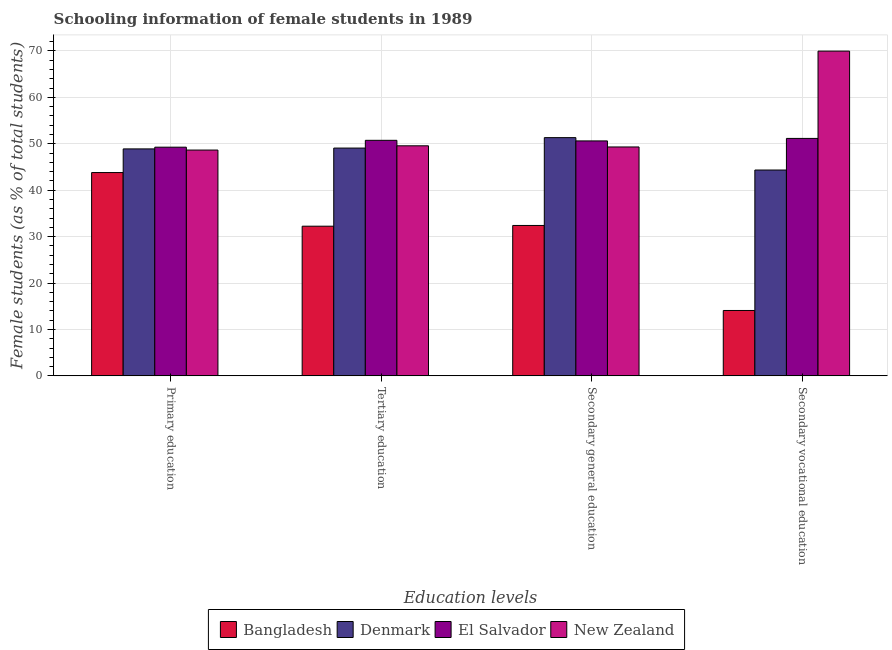How many different coloured bars are there?
Provide a short and direct response. 4. Are the number of bars per tick equal to the number of legend labels?
Provide a short and direct response. Yes. Are the number of bars on each tick of the X-axis equal?
Give a very brief answer. Yes. How many bars are there on the 1st tick from the left?
Give a very brief answer. 4. What is the label of the 1st group of bars from the left?
Your answer should be very brief. Primary education. What is the percentage of female students in primary education in Bangladesh?
Give a very brief answer. 43.8. Across all countries, what is the maximum percentage of female students in secondary vocational education?
Your answer should be very brief. 69.96. Across all countries, what is the minimum percentage of female students in secondary vocational education?
Offer a very short reply. 14.09. In which country was the percentage of female students in tertiary education maximum?
Offer a terse response. El Salvador. What is the total percentage of female students in secondary education in the graph?
Ensure brevity in your answer.  183.65. What is the difference between the percentage of female students in secondary vocational education in New Zealand and that in Bangladesh?
Keep it short and to the point. 55.87. What is the difference between the percentage of female students in tertiary education in Bangladesh and the percentage of female students in secondary vocational education in Denmark?
Offer a very short reply. -12.1. What is the average percentage of female students in primary education per country?
Make the answer very short. 47.65. What is the difference between the percentage of female students in primary education and percentage of female students in secondary vocational education in Denmark?
Provide a short and direct response. 4.55. What is the ratio of the percentage of female students in secondary education in El Salvador to that in New Zealand?
Offer a very short reply. 1.03. Is the difference between the percentage of female students in primary education in Bangladesh and New Zealand greater than the difference between the percentage of female students in secondary education in Bangladesh and New Zealand?
Provide a short and direct response. Yes. What is the difference between the highest and the second highest percentage of female students in secondary vocational education?
Offer a terse response. 18.81. What is the difference between the highest and the lowest percentage of female students in primary education?
Your answer should be compact. 5.46. In how many countries, is the percentage of female students in primary education greater than the average percentage of female students in primary education taken over all countries?
Provide a succinct answer. 3. What does the 3rd bar from the left in Tertiary education represents?
Provide a short and direct response. El Salvador. Is it the case that in every country, the sum of the percentage of female students in primary education and percentage of female students in tertiary education is greater than the percentage of female students in secondary education?
Provide a short and direct response. Yes. How many countries are there in the graph?
Ensure brevity in your answer.  4. What is the difference between two consecutive major ticks on the Y-axis?
Give a very brief answer. 10. Are the values on the major ticks of Y-axis written in scientific E-notation?
Provide a short and direct response. No. What is the title of the graph?
Your response must be concise. Schooling information of female students in 1989. What is the label or title of the X-axis?
Provide a short and direct response. Education levels. What is the label or title of the Y-axis?
Provide a short and direct response. Female students (as % of total students). What is the Female students (as % of total students) of Bangladesh in Primary education?
Ensure brevity in your answer.  43.8. What is the Female students (as % of total students) in Denmark in Primary education?
Your response must be concise. 48.89. What is the Female students (as % of total students) of El Salvador in Primary education?
Your answer should be very brief. 49.27. What is the Female students (as % of total students) in New Zealand in Primary education?
Ensure brevity in your answer.  48.64. What is the Female students (as % of total students) in Bangladesh in Tertiary education?
Offer a terse response. 32.24. What is the Female students (as % of total students) in Denmark in Tertiary education?
Your answer should be very brief. 49.07. What is the Female students (as % of total students) in El Salvador in Tertiary education?
Your answer should be very brief. 50.74. What is the Female students (as % of total students) in New Zealand in Tertiary education?
Ensure brevity in your answer.  49.56. What is the Female students (as % of total students) in Bangladesh in Secondary general education?
Make the answer very short. 32.4. What is the Female students (as % of total students) of Denmark in Secondary general education?
Ensure brevity in your answer.  51.32. What is the Female students (as % of total students) of El Salvador in Secondary general education?
Your response must be concise. 50.61. What is the Female students (as % of total students) of New Zealand in Secondary general education?
Keep it short and to the point. 49.31. What is the Female students (as % of total students) of Bangladesh in Secondary vocational education?
Offer a terse response. 14.09. What is the Female students (as % of total students) in Denmark in Secondary vocational education?
Provide a short and direct response. 44.34. What is the Female students (as % of total students) of El Salvador in Secondary vocational education?
Give a very brief answer. 51.16. What is the Female students (as % of total students) in New Zealand in Secondary vocational education?
Ensure brevity in your answer.  69.96. Across all Education levels, what is the maximum Female students (as % of total students) of Bangladesh?
Your answer should be compact. 43.8. Across all Education levels, what is the maximum Female students (as % of total students) in Denmark?
Your answer should be compact. 51.32. Across all Education levels, what is the maximum Female students (as % of total students) in El Salvador?
Your answer should be very brief. 51.16. Across all Education levels, what is the maximum Female students (as % of total students) in New Zealand?
Make the answer very short. 69.96. Across all Education levels, what is the minimum Female students (as % of total students) of Bangladesh?
Your response must be concise. 14.09. Across all Education levels, what is the minimum Female students (as % of total students) of Denmark?
Offer a very short reply. 44.34. Across all Education levels, what is the minimum Female students (as % of total students) in El Salvador?
Offer a very short reply. 49.27. Across all Education levels, what is the minimum Female students (as % of total students) of New Zealand?
Your answer should be compact. 48.64. What is the total Female students (as % of total students) in Bangladesh in the graph?
Offer a terse response. 122.53. What is the total Female students (as % of total students) in Denmark in the graph?
Offer a very short reply. 193.63. What is the total Female students (as % of total students) of El Salvador in the graph?
Give a very brief answer. 201.78. What is the total Female students (as % of total students) in New Zealand in the graph?
Give a very brief answer. 217.48. What is the difference between the Female students (as % of total students) of Bangladesh in Primary education and that in Tertiary education?
Your answer should be compact. 11.56. What is the difference between the Female students (as % of total students) in Denmark in Primary education and that in Tertiary education?
Make the answer very short. -0.18. What is the difference between the Female students (as % of total students) of El Salvador in Primary education and that in Tertiary education?
Give a very brief answer. -1.48. What is the difference between the Female students (as % of total students) in New Zealand in Primary education and that in Tertiary education?
Offer a terse response. -0.92. What is the difference between the Female students (as % of total students) in Bangladesh in Primary education and that in Secondary general education?
Your answer should be compact. 11.4. What is the difference between the Female students (as % of total students) in Denmark in Primary education and that in Secondary general education?
Make the answer very short. -2.43. What is the difference between the Female students (as % of total students) of El Salvador in Primary education and that in Secondary general education?
Provide a succinct answer. -1.35. What is the difference between the Female students (as % of total students) of New Zealand in Primary education and that in Secondary general education?
Your answer should be compact. -0.67. What is the difference between the Female students (as % of total students) of Bangladesh in Primary education and that in Secondary vocational education?
Keep it short and to the point. 29.71. What is the difference between the Female students (as % of total students) in Denmark in Primary education and that in Secondary vocational education?
Give a very brief answer. 4.55. What is the difference between the Female students (as % of total students) of El Salvador in Primary education and that in Secondary vocational education?
Provide a succinct answer. -1.89. What is the difference between the Female students (as % of total students) in New Zealand in Primary education and that in Secondary vocational education?
Offer a terse response. -21.32. What is the difference between the Female students (as % of total students) in Bangladesh in Tertiary education and that in Secondary general education?
Your answer should be compact. -0.16. What is the difference between the Female students (as % of total students) in Denmark in Tertiary education and that in Secondary general education?
Your response must be concise. -2.25. What is the difference between the Female students (as % of total students) of El Salvador in Tertiary education and that in Secondary general education?
Keep it short and to the point. 0.13. What is the difference between the Female students (as % of total students) in New Zealand in Tertiary education and that in Secondary general education?
Ensure brevity in your answer.  0.25. What is the difference between the Female students (as % of total students) in Bangladesh in Tertiary education and that in Secondary vocational education?
Your answer should be very brief. 18.16. What is the difference between the Female students (as % of total students) of Denmark in Tertiary education and that in Secondary vocational education?
Your response must be concise. 4.73. What is the difference between the Female students (as % of total students) of El Salvador in Tertiary education and that in Secondary vocational education?
Give a very brief answer. -0.41. What is the difference between the Female students (as % of total students) of New Zealand in Tertiary education and that in Secondary vocational education?
Make the answer very short. -20.4. What is the difference between the Female students (as % of total students) in Bangladesh in Secondary general education and that in Secondary vocational education?
Offer a terse response. 18.31. What is the difference between the Female students (as % of total students) of Denmark in Secondary general education and that in Secondary vocational education?
Provide a short and direct response. 6.98. What is the difference between the Female students (as % of total students) in El Salvador in Secondary general education and that in Secondary vocational education?
Offer a terse response. -0.54. What is the difference between the Female students (as % of total students) of New Zealand in Secondary general education and that in Secondary vocational education?
Ensure brevity in your answer.  -20.65. What is the difference between the Female students (as % of total students) of Bangladesh in Primary education and the Female students (as % of total students) of Denmark in Tertiary education?
Offer a very short reply. -5.27. What is the difference between the Female students (as % of total students) in Bangladesh in Primary education and the Female students (as % of total students) in El Salvador in Tertiary education?
Give a very brief answer. -6.94. What is the difference between the Female students (as % of total students) in Bangladesh in Primary education and the Female students (as % of total students) in New Zealand in Tertiary education?
Make the answer very short. -5.76. What is the difference between the Female students (as % of total students) in Denmark in Primary education and the Female students (as % of total students) in El Salvador in Tertiary education?
Your response must be concise. -1.85. What is the difference between the Female students (as % of total students) in Denmark in Primary education and the Female students (as % of total students) in New Zealand in Tertiary education?
Provide a short and direct response. -0.67. What is the difference between the Female students (as % of total students) of El Salvador in Primary education and the Female students (as % of total students) of New Zealand in Tertiary education?
Your response must be concise. -0.3. What is the difference between the Female students (as % of total students) in Bangladesh in Primary education and the Female students (as % of total students) in Denmark in Secondary general education?
Provide a short and direct response. -7.52. What is the difference between the Female students (as % of total students) in Bangladesh in Primary education and the Female students (as % of total students) in El Salvador in Secondary general education?
Provide a short and direct response. -6.81. What is the difference between the Female students (as % of total students) of Bangladesh in Primary education and the Female students (as % of total students) of New Zealand in Secondary general education?
Give a very brief answer. -5.51. What is the difference between the Female students (as % of total students) in Denmark in Primary education and the Female students (as % of total students) in El Salvador in Secondary general education?
Give a very brief answer. -1.72. What is the difference between the Female students (as % of total students) of Denmark in Primary education and the Female students (as % of total students) of New Zealand in Secondary general education?
Keep it short and to the point. -0.42. What is the difference between the Female students (as % of total students) in El Salvador in Primary education and the Female students (as % of total students) in New Zealand in Secondary general education?
Ensure brevity in your answer.  -0.05. What is the difference between the Female students (as % of total students) in Bangladesh in Primary education and the Female students (as % of total students) in Denmark in Secondary vocational education?
Ensure brevity in your answer.  -0.54. What is the difference between the Female students (as % of total students) of Bangladesh in Primary education and the Female students (as % of total students) of El Salvador in Secondary vocational education?
Give a very brief answer. -7.36. What is the difference between the Female students (as % of total students) in Bangladesh in Primary education and the Female students (as % of total students) in New Zealand in Secondary vocational education?
Your response must be concise. -26.16. What is the difference between the Female students (as % of total students) of Denmark in Primary education and the Female students (as % of total students) of El Salvador in Secondary vocational education?
Keep it short and to the point. -2.26. What is the difference between the Female students (as % of total students) of Denmark in Primary education and the Female students (as % of total students) of New Zealand in Secondary vocational education?
Make the answer very short. -21.07. What is the difference between the Female students (as % of total students) in El Salvador in Primary education and the Female students (as % of total students) in New Zealand in Secondary vocational education?
Give a very brief answer. -20.7. What is the difference between the Female students (as % of total students) in Bangladesh in Tertiary education and the Female students (as % of total students) in Denmark in Secondary general education?
Make the answer very short. -19.08. What is the difference between the Female students (as % of total students) of Bangladesh in Tertiary education and the Female students (as % of total students) of El Salvador in Secondary general education?
Your answer should be very brief. -18.37. What is the difference between the Female students (as % of total students) in Bangladesh in Tertiary education and the Female students (as % of total students) in New Zealand in Secondary general education?
Ensure brevity in your answer.  -17.07. What is the difference between the Female students (as % of total students) of Denmark in Tertiary education and the Female students (as % of total students) of El Salvador in Secondary general education?
Offer a very short reply. -1.54. What is the difference between the Female students (as % of total students) in Denmark in Tertiary education and the Female students (as % of total students) in New Zealand in Secondary general education?
Your answer should be compact. -0.24. What is the difference between the Female students (as % of total students) of El Salvador in Tertiary education and the Female students (as % of total students) of New Zealand in Secondary general education?
Ensure brevity in your answer.  1.43. What is the difference between the Female students (as % of total students) of Bangladesh in Tertiary education and the Female students (as % of total students) of Denmark in Secondary vocational education?
Your answer should be very brief. -12.1. What is the difference between the Female students (as % of total students) of Bangladesh in Tertiary education and the Female students (as % of total students) of El Salvador in Secondary vocational education?
Make the answer very short. -18.91. What is the difference between the Female students (as % of total students) of Bangladesh in Tertiary education and the Female students (as % of total students) of New Zealand in Secondary vocational education?
Provide a short and direct response. -37.72. What is the difference between the Female students (as % of total students) of Denmark in Tertiary education and the Female students (as % of total students) of El Salvador in Secondary vocational education?
Offer a very short reply. -2.08. What is the difference between the Female students (as % of total students) in Denmark in Tertiary education and the Female students (as % of total students) in New Zealand in Secondary vocational education?
Keep it short and to the point. -20.89. What is the difference between the Female students (as % of total students) of El Salvador in Tertiary education and the Female students (as % of total students) of New Zealand in Secondary vocational education?
Keep it short and to the point. -19.22. What is the difference between the Female students (as % of total students) in Bangladesh in Secondary general education and the Female students (as % of total students) in Denmark in Secondary vocational education?
Offer a terse response. -11.94. What is the difference between the Female students (as % of total students) in Bangladesh in Secondary general education and the Female students (as % of total students) in El Salvador in Secondary vocational education?
Provide a short and direct response. -18.76. What is the difference between the Female students (as % of total students) in Bangladesh in Secondary general education and the Female students (as % of total students) in New Zealand in Secondary vocational education?
Offer a very short reply. -37.56. What is the difference between the Female students (as % of total students) of Denmark in Secondary general education and the Female students (as % of total students) of El Salvador in Secondary vocational education?
Your response must be concise. 0.17. What is the difference between the Female students (as % of total students) of Denmark in Secondary general education and the Female students (as % of total students) of New Zealand in Secondary vocational education?
Your answer should be very brief. -18.64. What is the difference between the Female students (as % of total students) of El Salvador in Secondary general education and the Female students (as % of total students) of New Zealand in Secondary vocational education?
Offer a terse response. -19.35. What is the average Female students (as % of total students) in Bangladesh per Education levels?
Keep it short and to the point. 30.63. What is the average Female students (as % of total students) of Denmark per Education levels?
Your answer should be very brief. 48.41. What is the average Female students (as % of total students) in El Salvador per Education levels?
Offer a very short reply. 50.44. What is the average Female students (as % of total students) in New Zealand per Education levels?
Offer a very short reply. 54.37. What is the difference between the Female students (as % of total students) of Bangladesh and Female students (as % of total students) of Denmark in Primary education?
Offer a very short reply. -5.09. What is the difference between the Female students (as % of total students) in Bangladesh and Female students (as % of total students) in El Salvador in Primary education?
Your answer should be very brief. -5.46. What is the difference between the Female students (as % of total students) in Bangladesh and Female students (as % of total students) in New Zealand in Primary education?
Offer a terse response. -4.84. What is the difference between the Female students (as % of total students) of Denmark and Female students (as % of total students) of El Salvador in Primary education?
Provide a succinct answer. -0.37. What is the difference between the Female students (as % of total students) of Denmark and Female students (as % of total students) of New Zealand in Primary education?
Your answer should be compact. 0.25. What is the difference between the Female students (as % of total students) in El Salvador and Female students (as % of total students) in New Zealand in Primary education?
Your answer should be very brief. 0.62. What is the difference between the Female students (as % of total students) of Bangladesh and Female students (as % of total students) of Denmark in Tertiary education?
Ensure brevity in your answer.  -16.83. What is the difference between the Female students (as % of total students) of Bangladesh and Female students (as % of total students) of El Salvador in Tertiary education?
Offer a very short reply. -18.5. What is the difference between the Female students (as % of total students) of Bangladesh and Female students (as % of total students) of New Zealand in Tertiary education?
Ensure brevity in your answer.  -17.32. What is the difference between the Female students (as % of total students) in Denmark and Female students (as % of total students) in El Salvador in Tertiary education?
Provide a short and direct response. -1.67. What is the difference between the Female students (as % of total students) in Denmark and Female students (as % of total students) in New Zealand in Tertiary education?
Make the answer very short. -0.49. What is the difference between the Female students (as % of total students) of El Salvador and Female students (as % of total students) of New Zealand in Tertiary education?
Give a very brief answer. 1.18. What is the difference between the Female students (as % of total students) of Bangladesh and Female students (as % of total students) of Denmark in Secondary general education?
Give a very brief answer. -18.92. What is the difference between the Female students (as % of total students) of Bangladesh and Female students (as % of total students) of El Salvador in Secondary general education?
Offer a very short reply. -18.21. What is the difference between the Female students (as % of total students) of Bangladesh and Female students (as % of total students) of New Zealand in Secondary general education?
Your response must be concise. -16.91. What is the difference between the Female students (as % of total students) of Denmark and Female students (as % of total students) of El Salvador in Secondary general education?
Offer a terse response. 0.71. What is the difference between the Female students (as % of total students) of Denmark and Female students (as % of total students) of New Zealand in Secondary general education?
Give a very brief answer. 2.01. What is the difference between the Female students (as % of total students) of El Salvador and Female students (as % of total students) of New Zealand in Secondary general education?
Give a very brief answer. 1.3. What is the difference between the Female students (as % of total students) of Bangladesh and Female students (as % of total students) of Denmark in Secondary vocational education?
Provide a short and direct response. -30.26. What is the difference between the Female students (as % of total students) in Bangladesh and Female students (as % of total students) in El Salvador in Secondary vocational education?
Your answer should be very brief. -37.07. What is the difference between the Female students (as % of total students) of Bangladesh and Female students (as % of total students) of New Zealand in Secondary vocational education?
Your answer should be very brief. -55.87. What is the difference between the Female students (as % of total students) in Denmark and Female students (as % of total students) in El Salvador in Secondary vocational education?
Give a very brief answer. -6.81. What is the difference between the Female students (as % of total students) of Denmark and Female students (as % of total students) of New Zealand in Secondary vocational education?
Keep it short and to the point. -25.62. What is the difference between the Female students (as % of total students) of El Salvador and Female students (as % of total students) of New Zealand in Secondary vocational education?
Your response must be concise. -18.81. What is the ratio of the Female students (as % of total students) in Bangladesh in Primary education to that in Tertiary education?
Make the answer very short. 1.36. What is the ratio of the Female students (as % of total students) in Denmark in Primary education to that in Tertiary education?
Make the answer very short. 1. What is the ratio of the Female students (as % of total students) of El Salvador in Primary education to that in Tertiary education?
Provide a short and direct response. 0.97. What is the ratio of the Female students (as % of total students) in New Zealand in Primary education to that in Tertiary education?
Offer a very short reply. 0.98. What is the ratio of the Female students (as % of total students) of Bangladesh in Primary education to that in Secondary general education?
Give a very brief answer. 1.35. What is the ratio of the Female students (as % of total students) of Denmark in Primary education to that in Secondary general education?
Provide a short and direct response. 0.95. What is the ratio of the Female students (as % of total students) in El Salvador in Primary education to that in Secondary general education?
Keep it short and to the point. 0.97. What is the ratio of the Female students (as % of total students) of New Zealand in Primary education to that in Secondary general education?
Make the answer very short. 0.99. What is the ratio of the Female students (as % of total students) of Bangladesh in Primary education to that in Secondary vocational education?
Your answer should be compact. 3.11. What is the ratio of the Female students (as % of total students) of Denmark in Primary education to that in Secondary vocational education?
Offer a very short reply. 1.1. What is the ratio of the Female students (as % of total students) of New Zealand in Primary education to that in Secondary vocational education?
Provide a short and direct response. 0.7. What is the ratio of the Female students (as % of total students) of Bangladesh in Tertiary education to that in Secondary general education?
Ensure brevity in your answer.  1. What is the ratio of the Female students (as % of total students) of Denmark in Tertiary education to that in Secondary general education?
Give a very brief answer. 0.96. What is the ratio of the Female students (as % of total students) in Bangladesh in Tertiary education to that in Secondary vocational education?
Provide a short and direct response. 2.29. What is the ratio of the Female students (as % of total students) in Denmark in Tertiary education to that in Secondary vocational education?
Provide a short and direct response. 1.11. What is the ratio of the Female students (as % of total students) of El Salvador in Tertiary education to that in Secondary vocational education?
Give a very brief answer. 0.99. What is the ratio of the Female students (as % of total students) in New Zealand in Tertiary education to that in Secondary vocational education?
Give a very brief answer. 0.71. What is the ratio of the Female students (as % of total students) of Bangladesh in Secondary general education to that in Secondary vocational education?
Make the answer very short. 2.3. What is the ratio of the Female students (as % of total students) in Denmark in Secondary general education to that in Secondary vocational education?
Ensure brevity in your answer.  1.16. What is the ratio of the Female students (as % of total students) in New Zealand in Secondary general education to that in Secondary vocational education?
Offer a terse response. 0.7. What is the difference between the highest and the second highest Female students (as % of total students) in Bangladesh?
Make the answer very short. 11.4. What is the difference between the highest and the second highest Female students (as % of total students) in Denmark?
Ensure brevity in your answer.  2.25. What is the difference between the highest and the second highest Female students (as % of total students) of El Salvador?
Your response must be concise. 0.41. What is the difference between the highest and the second highest Female students (as % of total students) of New Zealand?
Your response must be concise. 20.4. What is the difference between the highest and the lowest Female students (as % of total students) of Bangladesh?
Provide a short and direct response. 29.71. What is the difference between the highest and the lowest Female students (as % of total students) in Denmark?
Make the answer very short. 6.98. What is the difference between the highest and the lowest Female students (as % of total students) in El Salvador?
Make the answer very short. 1.89. What is the difference between the highest and the lowest Female students (as % of total students) in New Zealand?
Your answer should be compact. 21.32. 